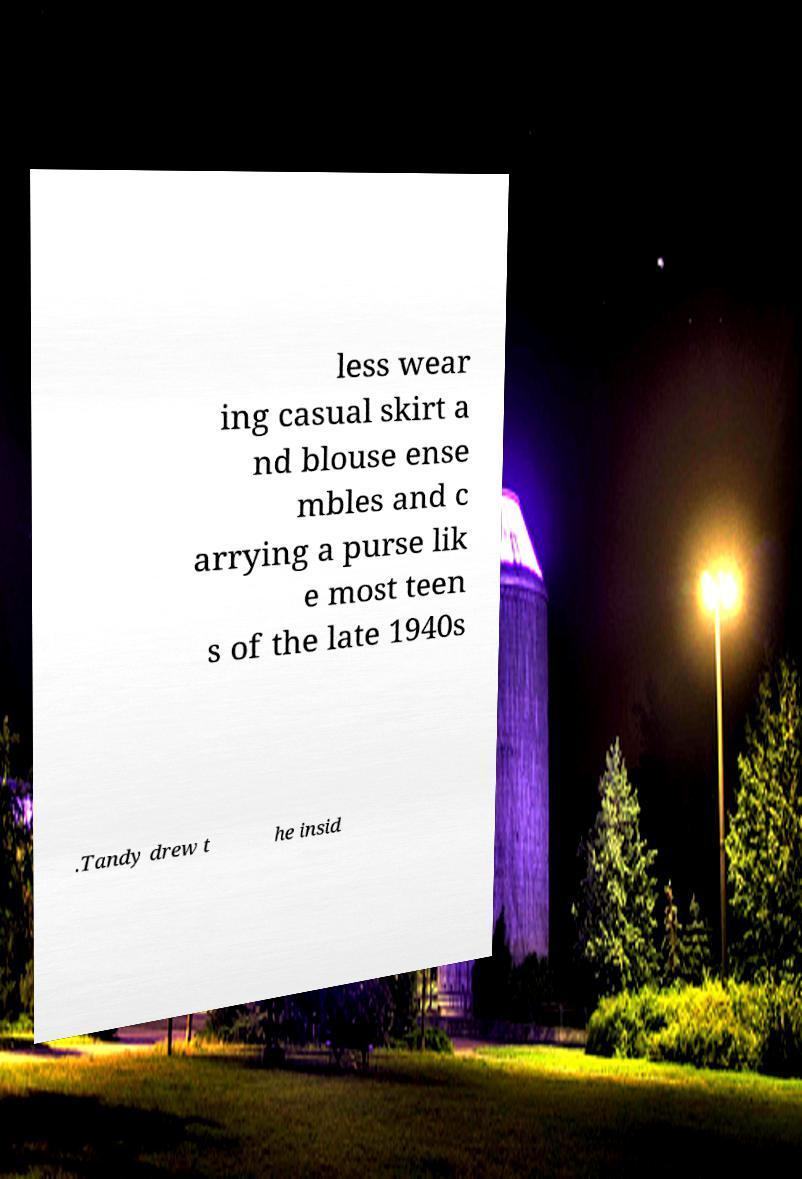Please read and relay the text visible in this image. What does it say? less wear ing casual skirt a nd blouse ense mbles and c arrying a purse lik e most teen s of the late 1940s .Tandy drew t he insid 